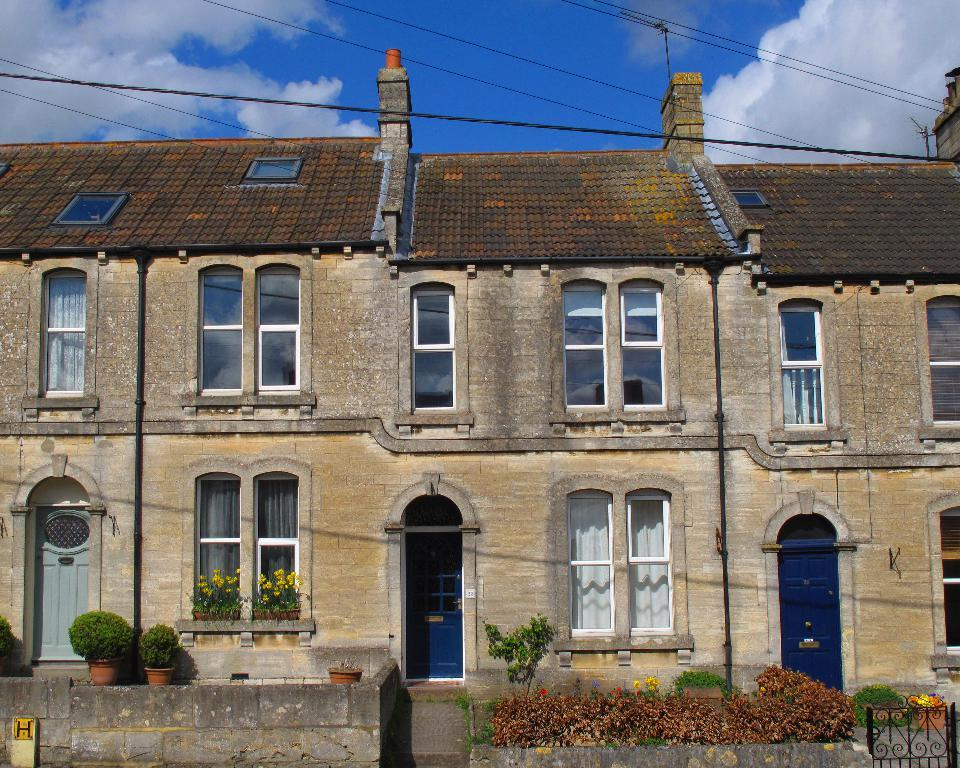What type of structure is visible in the image? There is a building in the image. How many doors and windows can be seen on the building? The building has many doors and windows. What can be found in front of the building? There are plant pots and plants in front of the building. What is visible above the building? The sky is visible above the building. What can be observed in the sky? Clouds are present in the sky. Where is the pipe located in the image? There is no pipe present in the image. Can you see a hen in the image? There is no hen present in the image. 